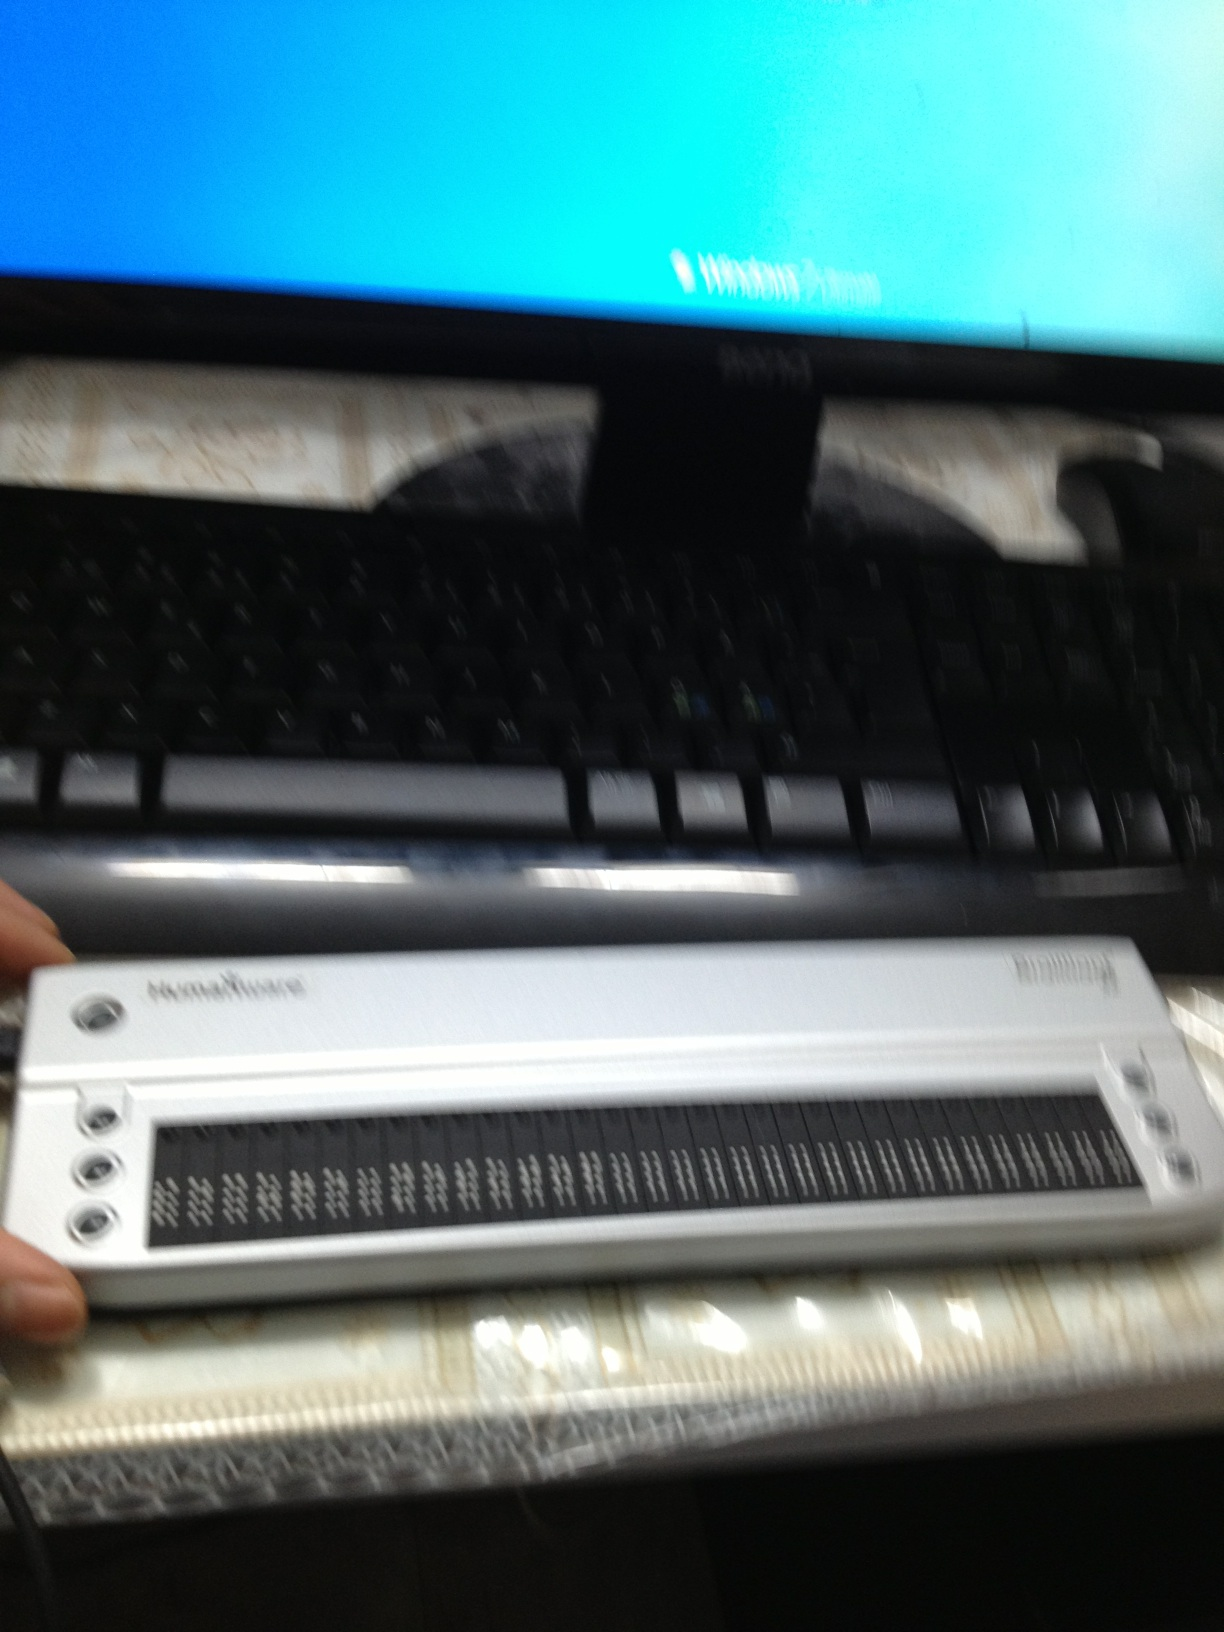Create a short story based on the items in the image. In a small, tech-laden apartment, Jessie, a brilliant software developer who is visually impaired, worked tirelessly on creating software that translates multiple languages into braille in real-time. Her setup, consisting of a high-definition monitor and a refreshable braille display, was her window to the digital world. She discovered a way to make braille more accessible worldwide, changing the landscape of communication for millions of visually impaired individuals. Her innovation not only earned her recognition but also connected her with people globally, breaking down the barriers of language and disability. 